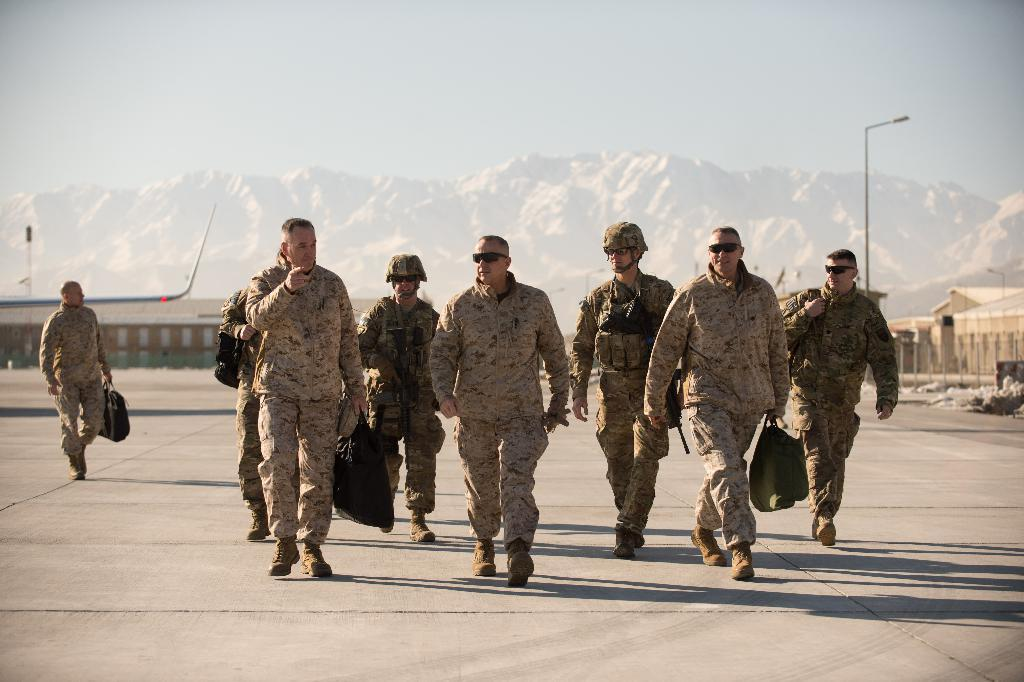What is happening in the foreground of the image? There are soldiers walking in the foreground of the image. What can be seen in the background of the image? There are houses, poles, mountains, and the sky visible in the background of the image. How many different types of structures are present in the background? There are three different types of structures in the background: houses, poles, and mountains. What type of breakfast is being served in the image? There is no breakfast present in the image; it features soldiers walking in the foreground and various structures in the background. Can you tell me how many mothers are visible in the image? There are no mothers visible in the image. 